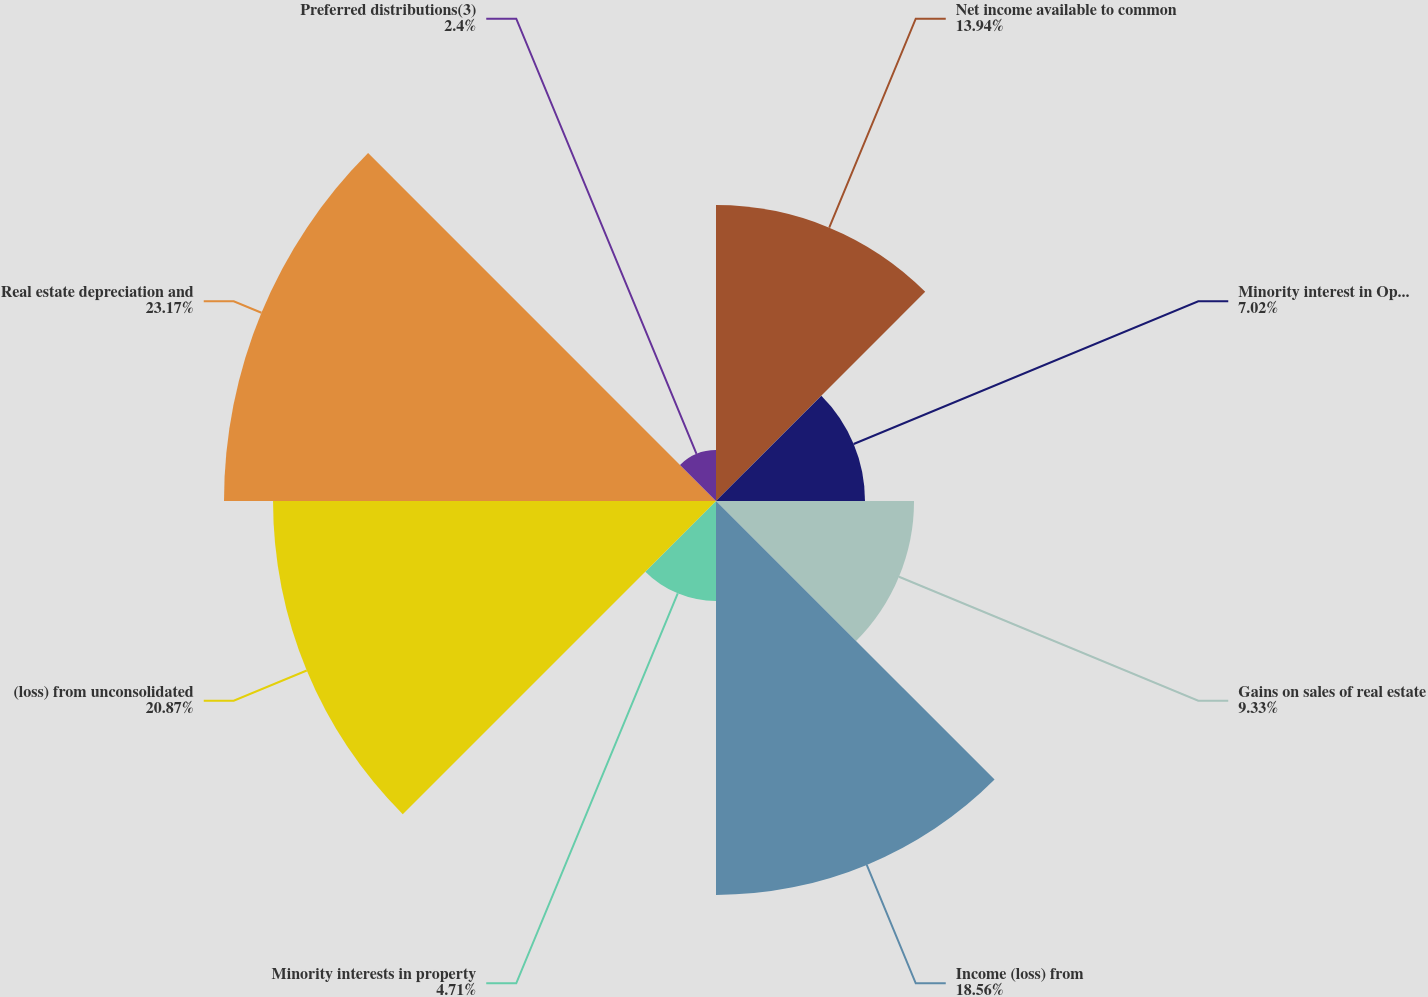Convert chart. <chart><loc_0><loc_0><loc_500><loc_500><pie_chart><fcel>Net income available to common<fcel>Minority interest in Operating<fcel>Gains on sales of real estate<fcel>Income (loss) from<fcel>Minority interests in property<fcel>(loss) from unconsolidated<fcel>Real estate depreciation and<fcel>Preferred distributions(3)<nl><fcel>13.94%<fcel>7.02%<fcel>9.33%<fcel>18.56%<fcel>4.71%<fcel>20.87%<fcel>23.18%<fcel>2.4%<nl></chart> 